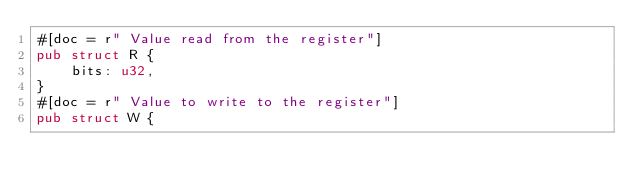Convert code to text. <code><loc_0><loc_0><loc_500><loc_500><_Rust_>#[doc = r" Value read from the register"]
pub struct R {
    bits: u32,
}
#[doc = r" Value to write to the register"]
pub struct W {</code> 